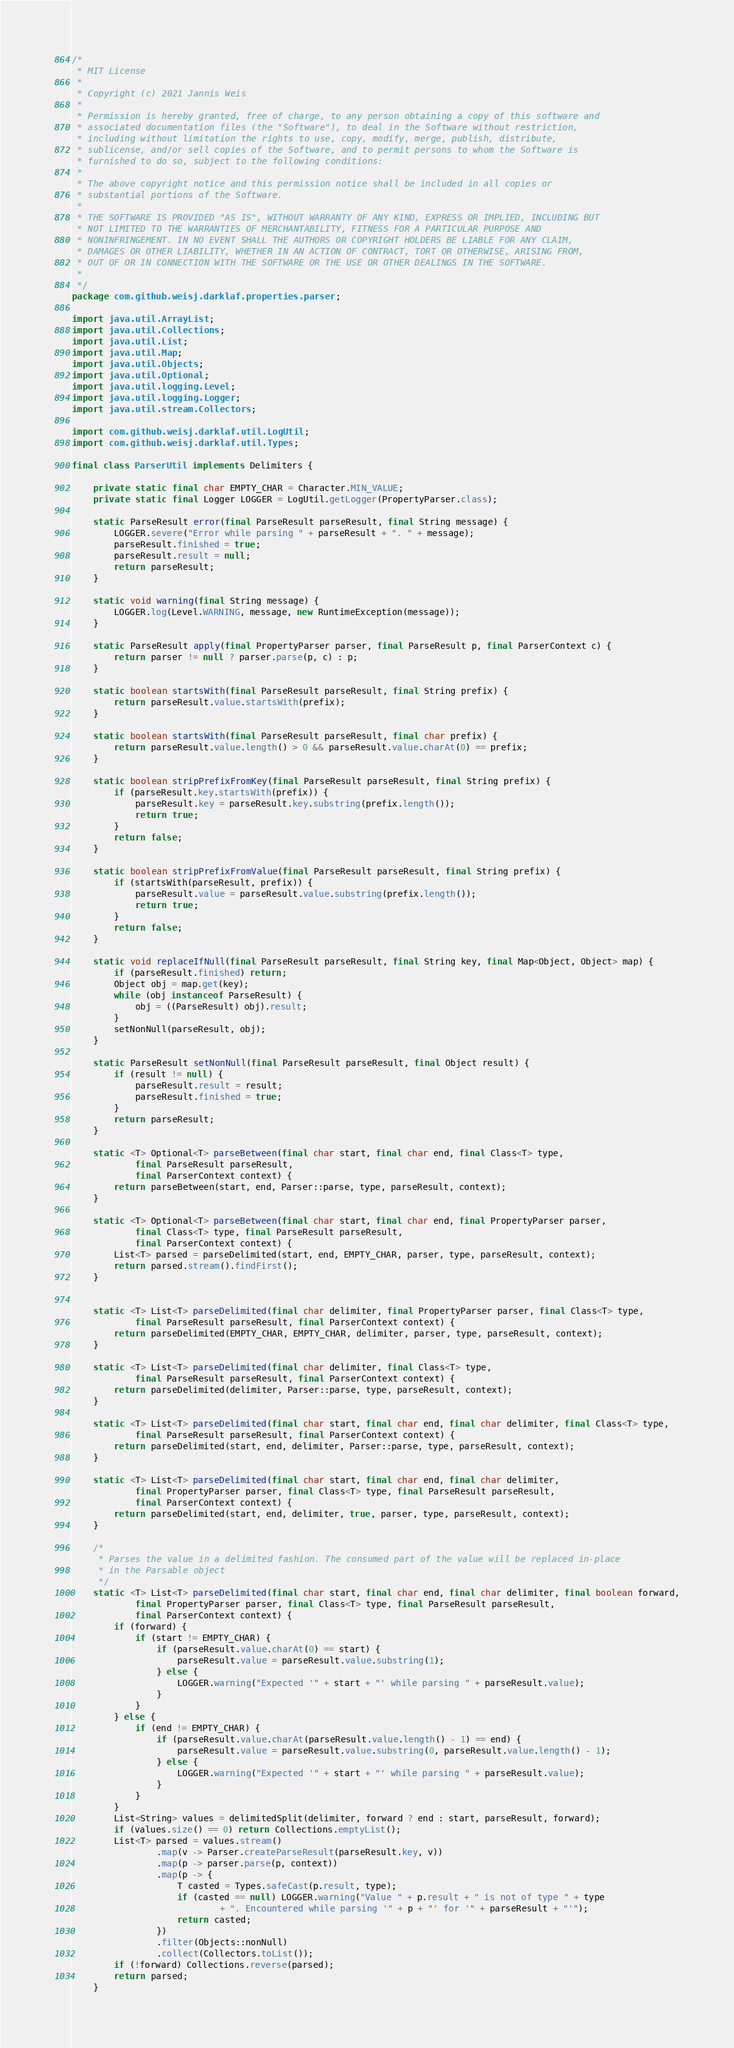<code> <loc_0><loc_0><loc_500><loc_500><_Java_>/*
 * MIT License
 *
 * Copyright (c) 2021 Jannis Weis
 *
 * Permission is hereby granted, free of charge, to any person obtaining a copy of this software and
 * associated documentation files (the "Software"), to deal in the Software without restriction,
 * including without limitation the rights to use, copy, modify, merge, publish, distribute,
 * sublicense, and/or sell copies of the Software, and to permit persons to whom the Software is
 * furnished to do so, subject to the following conditions:
 *
 * The above copyright notice and this permission notice shall be included in all copies or
 * substantial portions of the Software.
 *
 * THE SOFTWARE IS PROVIDED "AS IS", WITHOUT WARRANTY OF ANY KIND, EXPRESS OR IMPLIED, INCLUDING BUT
 * NOT LIMITED TO THE WARRANTIES OF MERCHANTABILITY, FITNESS FOR A PARTICULAR PURPOSE AND
 * NONINFRINGEMENT. IN NO EVENT SHALL THE AUTHORS OR COPYRIGHT HOLDERS BE LIABLE FOR ANY CLAIM,
 * DAMAGES OR OTHER LIABILITY, WHETHER IN AN ACTION OF CONTRACT, TORT OR OTHERWISE, ARISING FROM,
 * OUT OF OR IN CONNECTION WITH THE SOFTWARE OR THE USE OR OTHER DEALINGS IN THE SOFTWARE.
 *
 */
package com.github.weisj.darklaf.properties.parser;

import java.util.ArrayList;
import java.util.Collections;
import java.util.List;
import java.util.Map;
import java.util.Objects;
import java.util.Optional;
import java.util.logging.Level;
import java.util.logging.Logger;
import java.util.stream.Collectors;

import com.github.weisj.darklaf.util.LogUtil;
import com.github.weisj.darklaf.util.Types;

final class ParserUtil implements Delimiters {

    private static final char EMPTY_CHAR = Character.MIN_VALUE;
    private static final Logger LOGGER = LogUtil.getLogger(PropertyParser.class);

    static ParseResult error(final ParseResult parseResult, final String message) {
        LOGGER.severe("Error while parsing " + parseResult + ". " + message);
        parseResult.finished = true;
        parseResult.result = null;
        return parseResult;
    }

    static void warning(final String message) {
        LOGGER.log(Level.WARNING, message, new RuntimeException(message));
    }

    static ParseResult apply(final PropertyParser parser, final ParseResult p, final ParserContext c) {
        return parser != null ? parser.parse(p, c) : p;
    }

    static boolean startsWith(final ParseResult parseResult, final String prefix) {
        return parseResult.value.startsWith(prefix);
    }

    static boolean startsWith(final ParseResult parseResult, final char prefix) {
        return parseResult.value.length() > 0 && parseResult.value.charAt(0) == prefix;
    }

    static boolean stripPrefixFromKey(final ParseResult parseResult, final String prefix) {
        if (parseResult.key.startsWith(prefix)) {
            parseResult.key = parseResult.key.substring(prefix.length());
            return true;
        }
        return false;
    }

    static boolean stripPrefixFromValue(final ParseResult parseResult, final String prefix) {
        if (startsWith(parseResult, prefix)) {
            parseResult.value = parseResult.value.substring(prefix.length());
            return true;
        }
        return false;
    }

    static void replaceIfNull(final ParseResult parseResult, final String key, final Map<Object, Object> map) {
        if (parseResult.finished) return;
        Object obj = map.get(key);
        while (obj instanceof ParseResult) {
            obj = ((ParseResult) obj).result;
        }
        setNonNull(parseResult, obj);
    }

    static ParseResult setNonNull(final ParseResult parseResult, final Object result) {
        if (result != null) {
            parseResult.result = result;
            parseResult.finished = true;
        }
        return parseResult;
    }

    static <T> Optional<T> parseBetween(final char start, final char end, final Class<T> type,
            final ParseResult parseResult,
            final ParserContext context) {
        return parseBetween(start, end, Parser::parse, type, parseResult, context);
    }

    static <T> Optional<T> parseBetween(final char start, final char end, final PropertyParser parser,
            final Class<T> type, final ParseResult parseResult,
            final ParserContext context) {
        List<T> parsed = parseDelimited(start, end, EMPTY_CHAR, parser, type, parseResult, context);
        return parsed.stream().findFirst();
    }


    static <T> List<T> parseDelimited(final char delimiter, final PropertyParser parser, final Class<T> type,
            final ParseResult parseResult, final ParserContext context) {
        return parseDelimited(EMPTY_CHAR, EMPTY_CHAR, delimiter, parser, type, parseResult, context);
    }

    static <T> List<T> parseDelimited(final char delimiter, final Class<T> type,
            final ParseResult parseResult, final ParserContext context) {
        return parseDelimited(delimiter, Parser::parse, type, parseResult, context);
    }

    static <T> List<T> parseDelimited(final char start, final char end, final char delimiter, final Class<T> type,
            final ParseResult parseResult, final ParserContext context) {
        return parseDelimited(start, end, delimiter, Parser::parse, type, parseResult, context);
    }

    static <T> List<T> parseDelimited(final char start, final char end, final char delimiter,
            final PropertyParser parser, final Class<T> type, final ParseResult parseResult,
            final ParserContext context) {
        return parseDelimited(start, end, delimiter, true, parser, type, parseResult, context);
    }

    /*
     * Parses the value in a delimited fashion. The consumed part of the value will be replaced in-place
     * in the Parsable object
     */
    static <T> List<T> parseDelimited(final char start, final char end, final char delimiter, final boolean forward,
            final PropertyParser parser, final Class<T> type, final ParseResult parseResult,
            final ParserContext context) {
        if (forward) {
            if (start != EMPTY_CHAR) {
                if (parseResult.value.charAt(0) == start) {
                    parseResult.value = parseResult.value.substring(1);
                } else {
                    LOGGER.warning("Expected '" + start + "' while parsing " + parseResult.value);
                }
            }
        } else {
            if (end != EMPTY_CHAR) {
                if (parseResult.value.charAt(parseResult.value.length() - 1) == end) {
                    parseResult.value = parseResult.value.substring(0, parseResult.value.length() - 1);
                } else {
                    LOGGER.warning("Expected '" + start + "' while parsing " + parseResult.value);
                }
            }
        }
        List<String> values = delimitedSplit(delimiter, forward ? end : start, parseResult, forward);
        if (values.size() == 0) return Collections.emptyList();
        List<T> parsed = values.stream()
                .map(v -> Parser.createParseResult(parseResult.key, v))
                .map(p -> parser.parse(p, context))
                .map(p -> {
                    T casted = Types.safeCast(p.result, type);
                    if (casted == null) LOGGER.warning("Value " + p.result + " is not of type " + type
                            + ". Encountered while parsing '" + p + "' for '" + parseResult + "'");
                    return casted;
                })
                .filter(Objects::nonNull)
                .collect(Collectors.toList());
        if (!forward) Collections.reverse(parsed);
        return parsed;
    }
</code> 